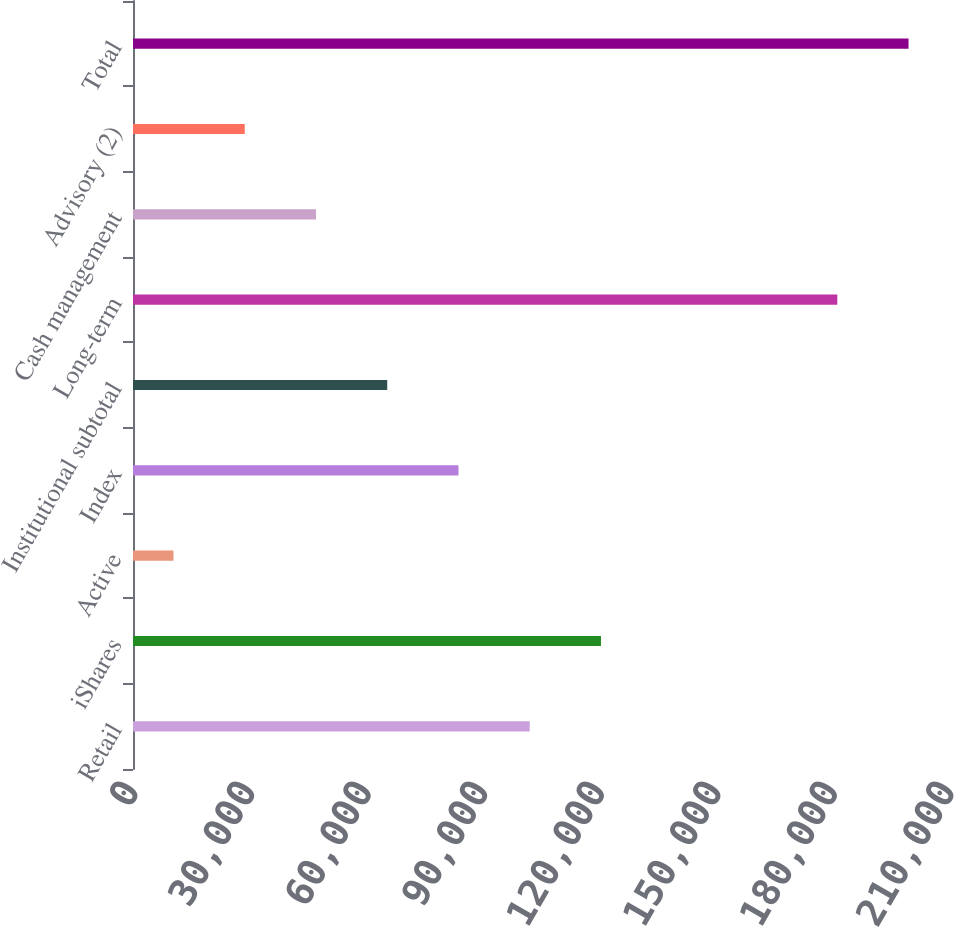Convert chart to OTSL. <chart><loc_0><loc_0><loc_500><loc_500><bar_chart><fcel>Retail<fcel>iShares<fcel>Active<fcel>Index<fcel>Institutional subtotal<fcel>Long-term<fcel>Cash management<fcel>Advisory (2)<fcel>Total<nl><fcel>102098<fcel>120434<fcel>10420<fcel>83762.4<fcel>65426.8<fcel>181253<fcel>47091.2<fcel>28755.6<fcel>199589<nl></chart> 